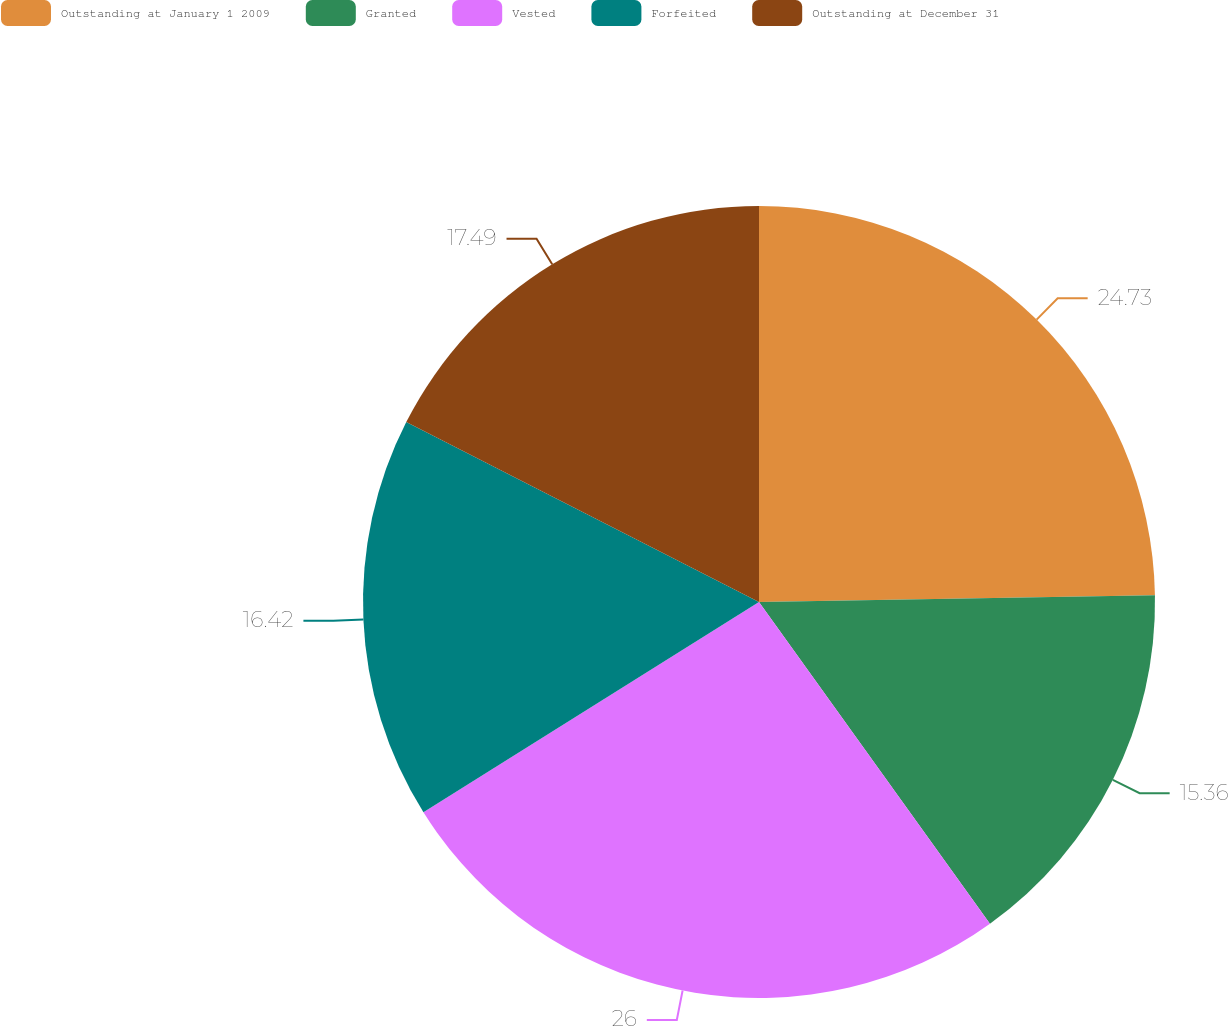<chart> <loc_0><loc_0><loc_500><loc_500><pie_chart><fcel>Outstanding at January 1 2009<fcel>Granted<fcel>Vested<fcel>Forfeited<fcel>Outstanding at December 31<nl><fcel>24.73%<fcel>15.36%<fcel>26.0%<fcel>16.42%<fcel>17.49%<nl></chart> 